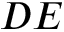<formula> <loc_0><loc_0><loc_500><loc_500>D E</formula> 